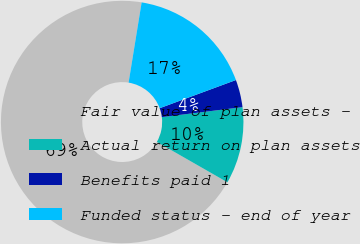<chart> <loc_0><loc_0><loc_500><loc_500><pie_chart><fcel>Fair value of plan assets -<fcel>Actual return on plan assets<fcel>Benefits paid 1<fcel>Funded status - end of year<nl><fcel>69.29%<fcel>10.24%<fcel>3.67%<fcel>16.8%<nl></chart> 